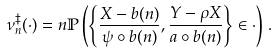<formula> <loc_0><loc_0><loc_500><loc_500>\nu _ { n } ^ { \ddag } ( \cdot ) = n \mathbb { P } \left ( \left \{ \frac { X - b ( n ) } { \psi \circ b ( n ) } , \frac { Y - \rho X } { a \circ b ( n ) } \right \} \in \cdot \right ) \, .</formula> 